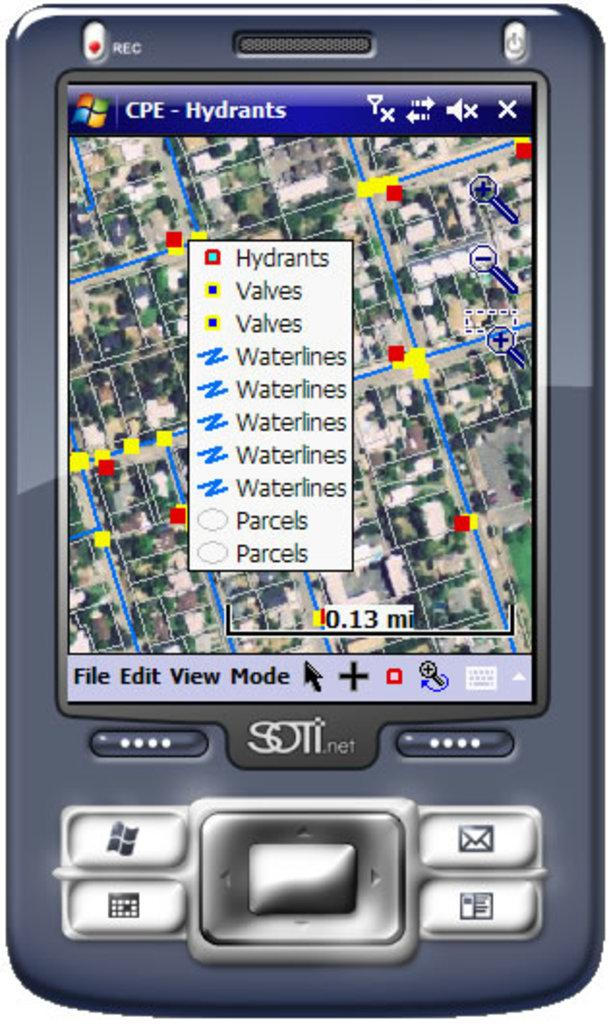<image>
Describe the image concisely. The silver cell phone is made by SOTI.net 